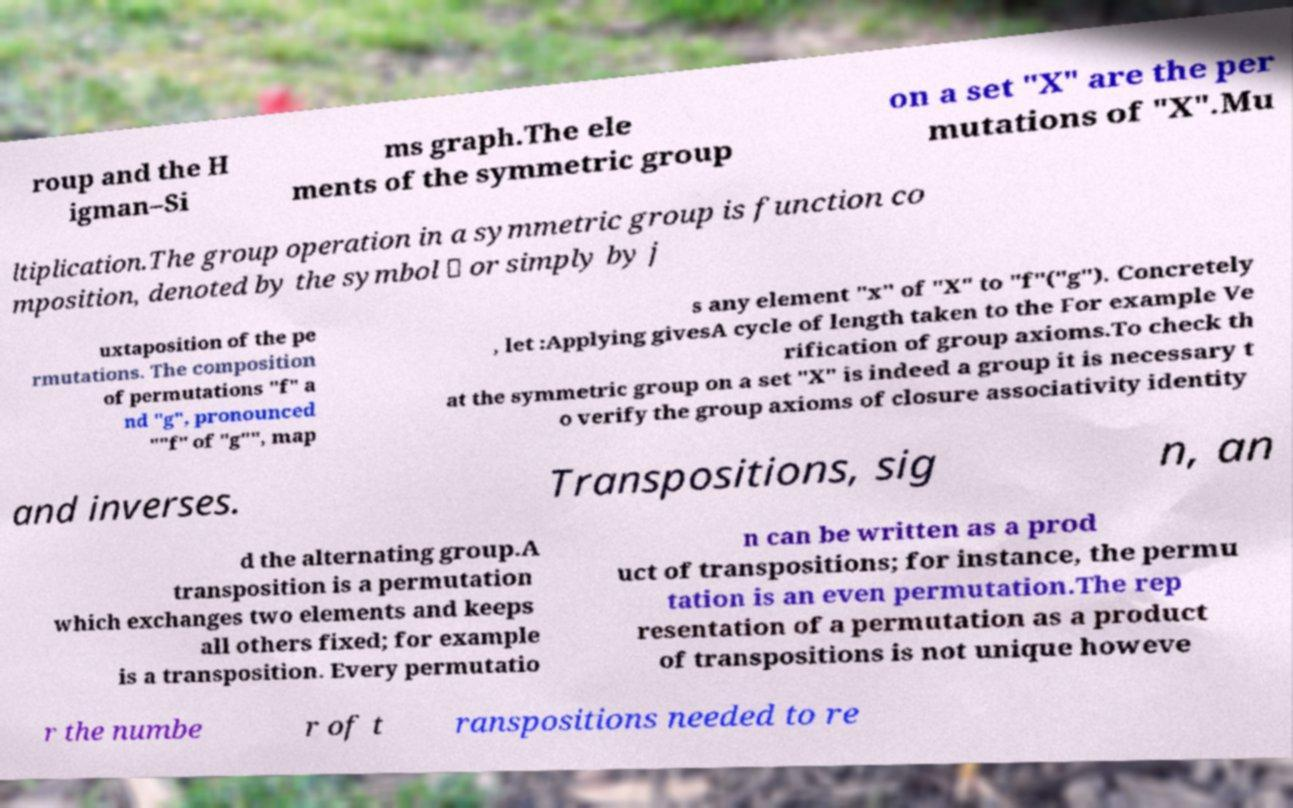Please identify and transcribe the text found in this image. roup and the H igman–Si ms graph.The ele ments of the symmetric group on a set "X" are the per mutations of "X".Mu ltiplication.The group operation in a symmetric group is function co mposition, denoted by the symbol ∘ or simply by j uxtaposition of the pe rmutations. The composition of permutations "f" a nd "g", pronounced ""f" of "g"", map s any element "x" of "X" to "f"("g"). Concretely , let :Applying givesA cycle of length taken to the For example Ve rification of group axioms.To check th at the symmetric group on a set "X" is indeed a group it is necessary t o verify the group axioms of closure associativity identity and inverses. Transpositions, sig n, an d the alternating group.A transposition is a permutation which exchanges two elements and keeps all others fixed; for example is a transposition. Every permutatio n can be written as a prod uct of transpositions; for instance, the permu tation is an even permutation.The rep resentation of a permutation as a product of transpositions is not unique howeve r the numbe r of t ranspositions needed to re 